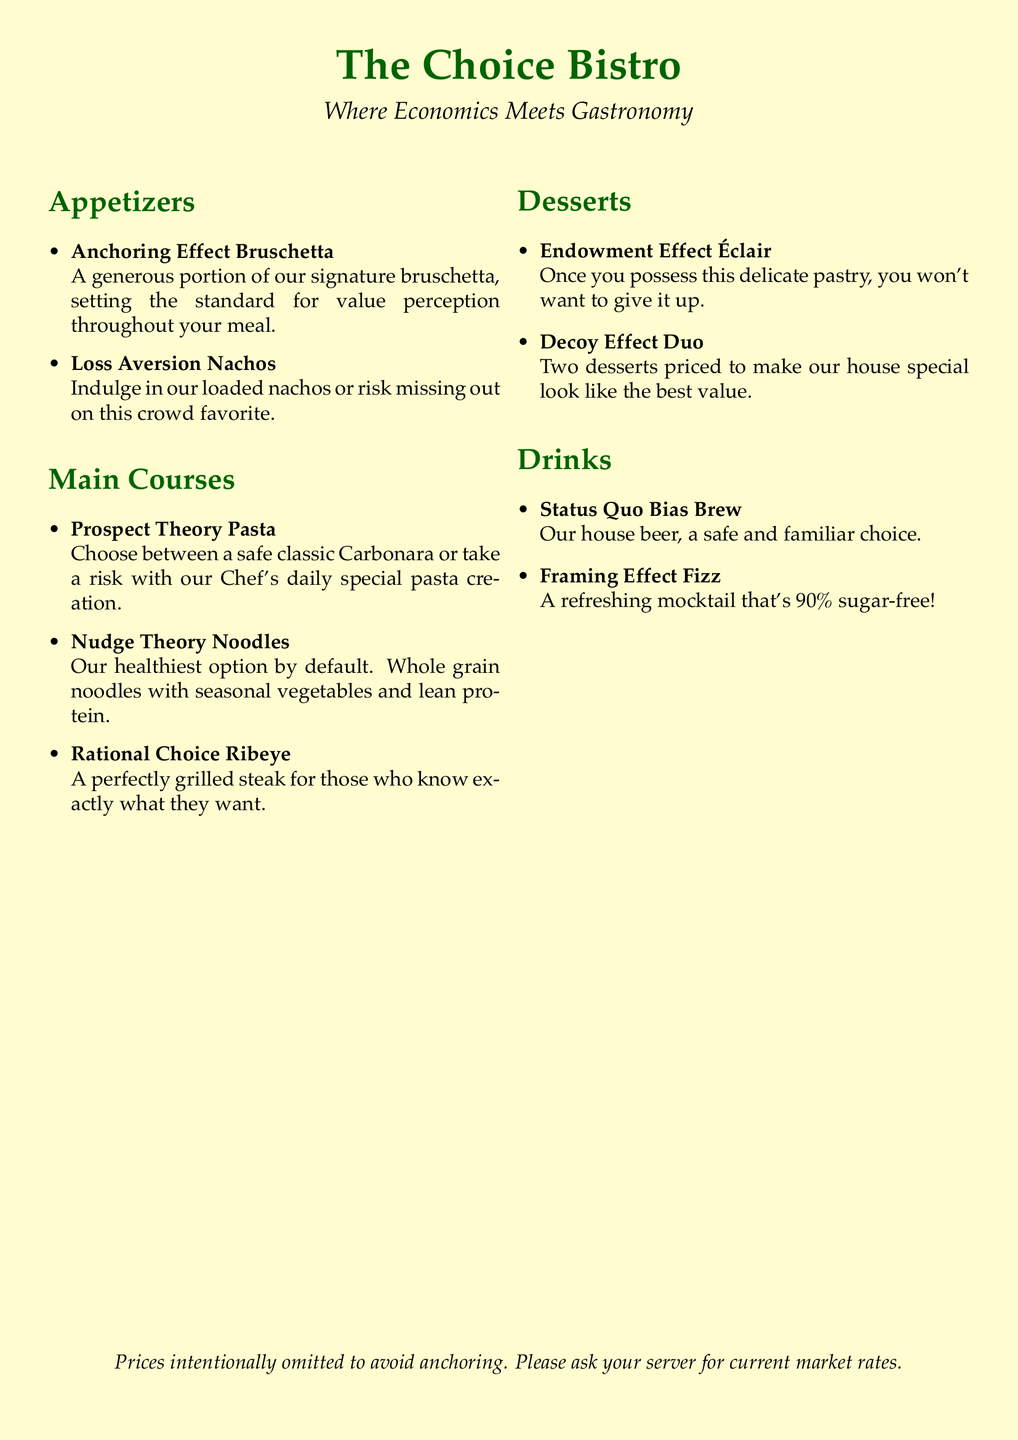What is the name of the restaurant? The name of the restaurant is mentioned at the top of the document.
Answer: The Choice Bistro What is the theme of the restaurant? The theme is described in the tagline below the restaurant name.
Answer: Where Economics Meets Gastronomy What appetizer mentions a consumer psychology concept related to perceived value? This dish sets a standard for value perception.
Answer: Anchoring Effect Bruschetta What main course offers a choice between a safe and a risky option? This dish is specifically about choosing between different types of pasta.
Answer: Prospect Theory Pasta Which dessert suggests that possession enhances feelings of ownership? This dessert is described in relation to not wanting to give it up once owned.
Answer: Endowment Effect Éclair What drink is described as a familiar choice? The drink aligns with a common consumer preference for known options.
Answer: Status Quo Bias Brew What theory is used to label the healthiest option on the menu? This concept reflects on guiding choices towards beneficial options.
Answer: Nudge Theory Noodles What dessert is designed to make a special stand out in terms of value? This dessert creates a contrast that highlights the perceived best value.
Answer: Decoy Effect Duo How is the pricing information presented? The document indicates how pricing details are shared with customers.
Answer: Prices intentionally omitted to avoid anchoring 